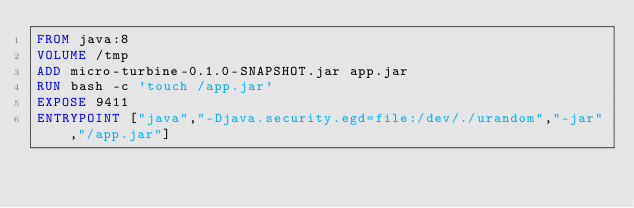<code> <loc_0><loc_0><loc_500><loc_500><_Dockerfile_>FROM java:8
VOLUME /tmp
ADD micro-turbine-0.1.0-SNAPSHOT.jar app.jar
RUN bash -c 'touch /app.jar'
EXPOSE 9411
ENTRYPOINT ["java","-Djava.security.egd=file:/dev/./urandom","-jar","/app.jar"]</code> 